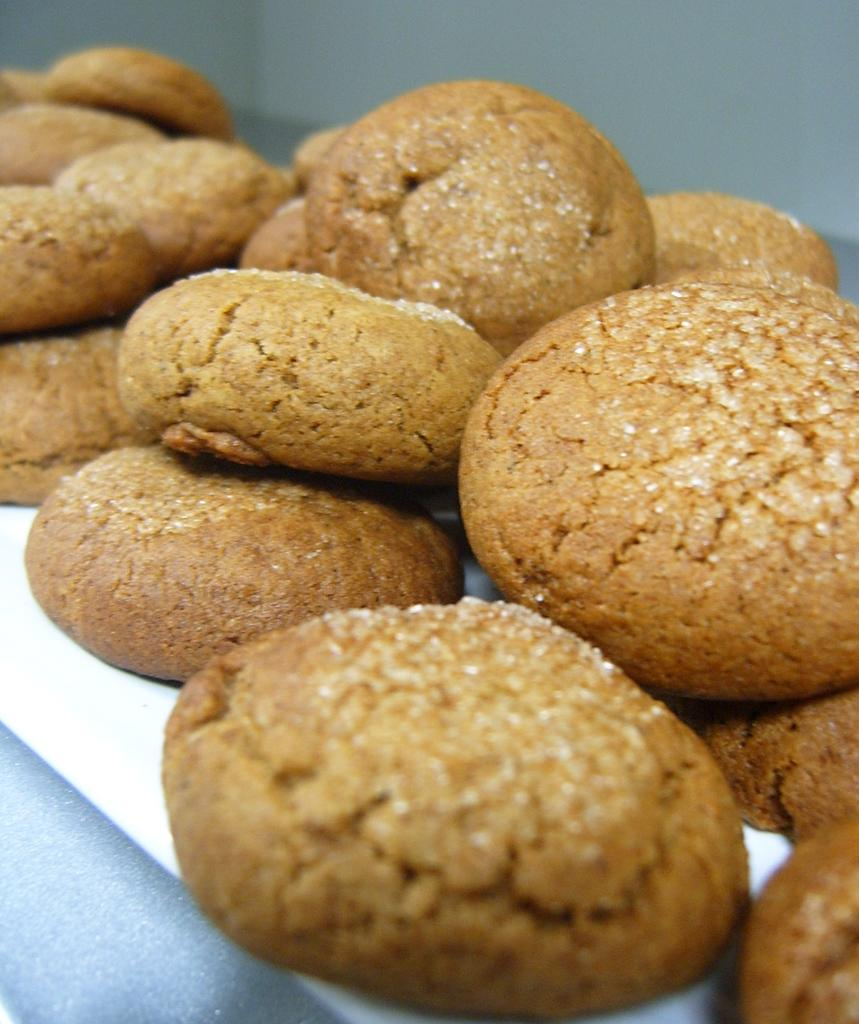What is the main subject of the image? The main subject of the image is food. Can you describe the background of the image? The background of the image is blurry. What type of ray can be seen swimming in the background of the image? There is no ray present in the image; the background is blurry and does not show any aquatic animals. 